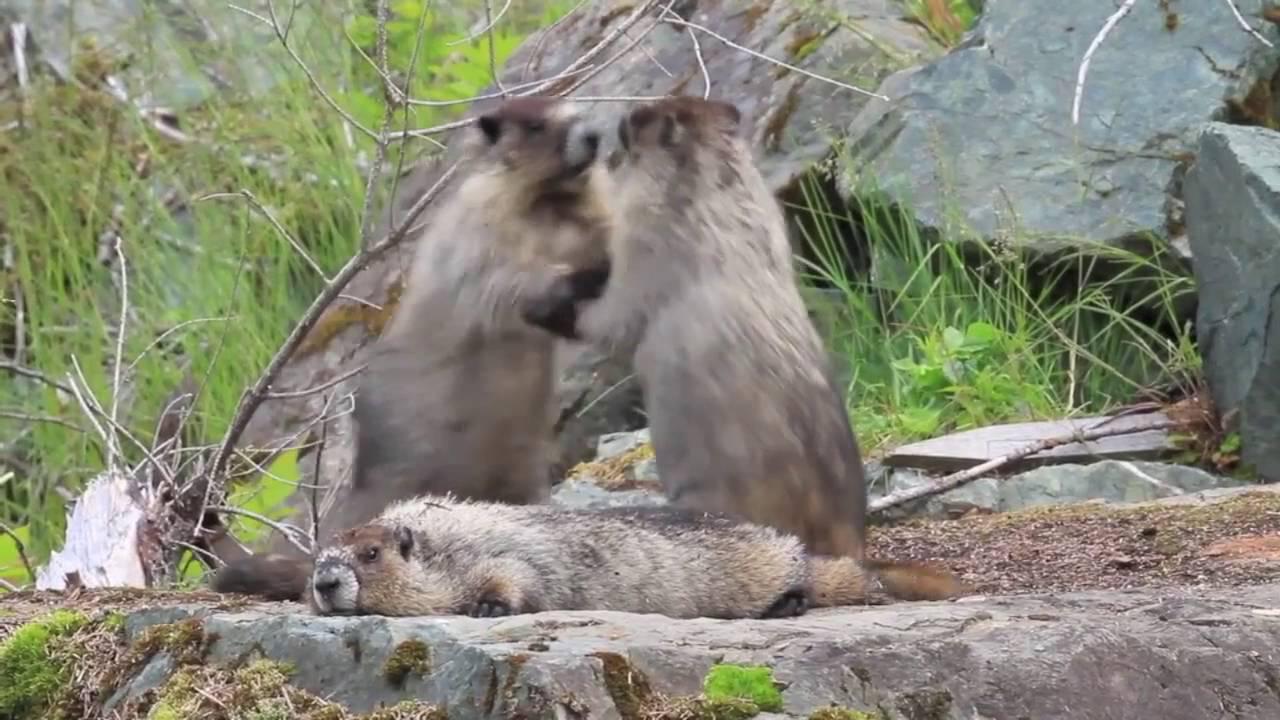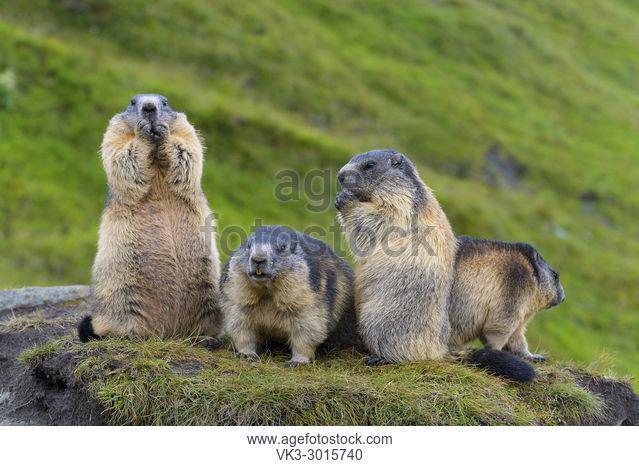The first image is the image on the left, the second image is the image on the right. Assess this claim about the two images: "At least three marmots are eating.". Correct or not? Answer yes or no. No. The first image is the image on the left, the second image is the image on the right. Considering the images on both sides, is "The left and right image contains the same number of prairie dogs." valid? Answer yes or no. No. 